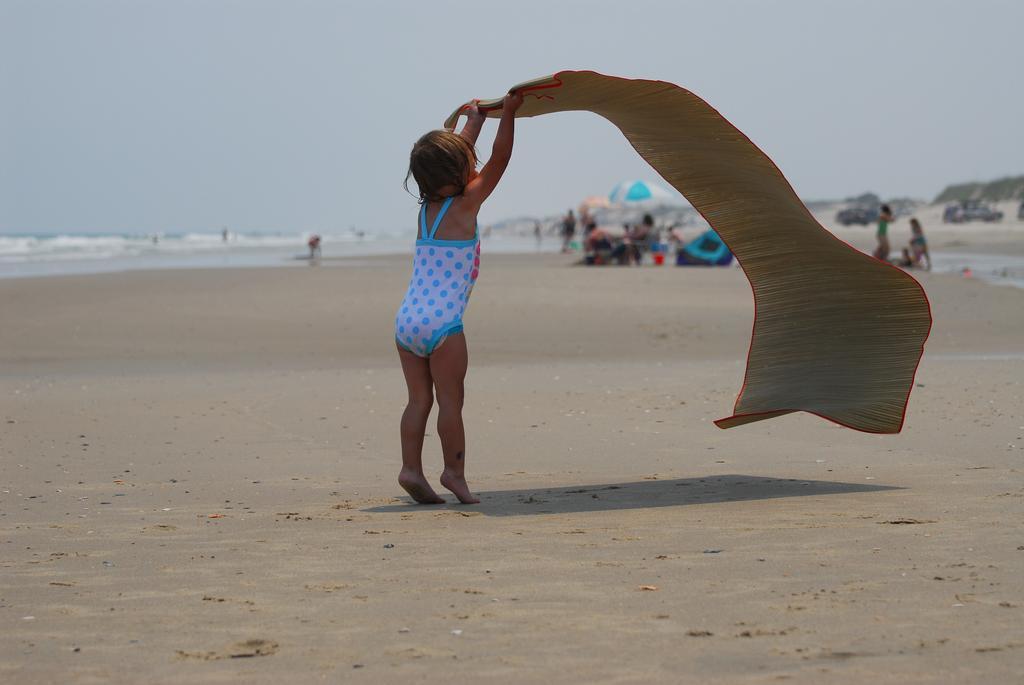In one or two sentences, can you explain what this image depicts? In this picture I can observe a girl standing in the beach. She is spreading a mat in the beach. In the background there are some people. I can observe an umbrella. There is an ocean and a sky. 